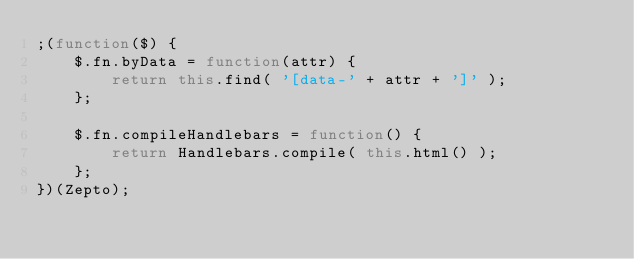<code> <loc_0><loc_0><loc_500><loc_500><_JavaScript_>;(function($) {
	$.fn.byData = function(attr) {
		return this.find( '[data-' + attr + ']' );
	};

	$.fn.compileHandlebars = function() {
		return Handlebars.compile( this.html() );
	};
})(Zepto);</code> 